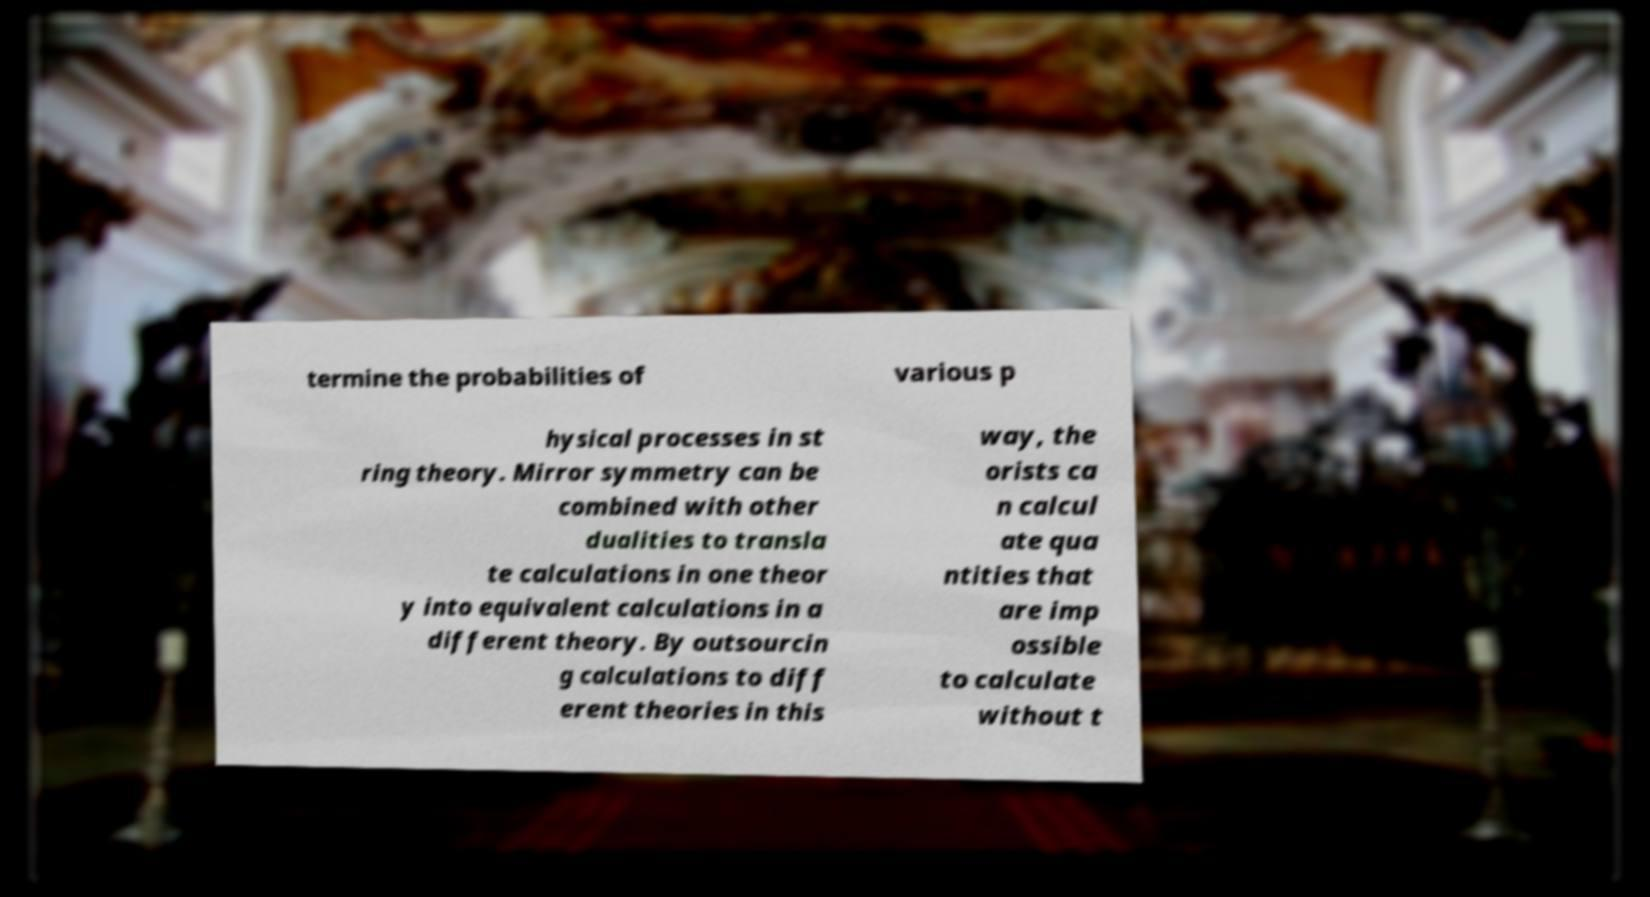There's text embedded in this image that I need extracted. Can you transcribe it verbatim? termine the probabilities of various p hysical processes in st ring theory. Mirror symmetry can be combined with other dualities to transla te calculations in one theor y into equivalent calculations in a different theory. By outsourcin g calculations to diff erent theories in this way, the orists ca n calcul ate qua ntities that are imp ossible to calculate without t 